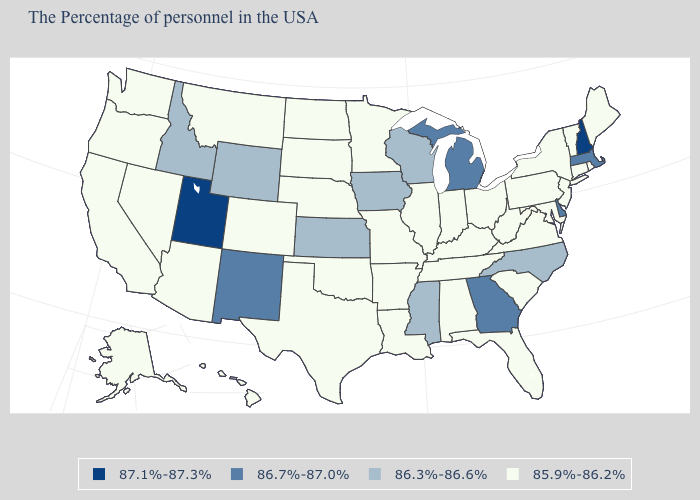Name the states that have a value in the range 85.9%-86.2%?
Be succinct. Maine, Rhode Island, Vermont, Connecticut, New York, New Jersey, Maryland, Pennsylvania, Virginia, South Carolina, West Virginia, Ohio, Florida, Kentucky, Indiana, Alabama, Tennessee, Illinois, Louisiana, Missouri, Arkansas, Minnesota, Nebraska, Oklahoma, Texas, South Dakota, North Dakota, Colorado, Montana, Arizona, Nevada, California, Washington, Oregon, Alaska, Hawaii. Name the states that have a value in the range 87.1%-87.3%?
Be succinct. New Hampshire, Utah. What is the value of Maryland?
Short answer required. 85.9%-86.2%. Name the states that have a value in the range 85.9%-86.2%?
Be succinct. Maine, Rhode Island, Vermont, Connecticut, New York, New Jersey, Maryland, Pennsylvania, Virginia, South Carolina, West Virginia, Ohio, Florida, Kentucky, Indiana, Alabama, Tennessee, Illinois, Louisiana, Missouri, Arkansas, Minnesota, Nebraska, Oklahoma, Texas, South Dakota, North Dakota, Colorado, Montana, Arizona, Nevada, California, Washington, Oregon, Alaska, Hawaii. What is the lowest value in the USA?
Quick response, please. 85.9%-86.2%. Name the states that have a value in the range 86.3%-86.6%?
Concise answer only. North Carolina, Wisconsin, Mississippi, Iowa, Kansas, Wyoming, Idaho. Does the first symbol in the legend represent the smallest category?
Quick response, please. No. What is the value of Arizona?
Quick response, please. 85.9%-86.2%. How many symbols are there in the legend?
Be succinct. 4. What is the value of Tennessee?
Short answer required. 85.9%-86.2%. Does Pennsylvania have the highest value in the Northeast?
Keep it brief. No. Does Mississippi have the lowest value in the USA?
Answer briefly. No. What is the value of South Dakota?
Short answer required. 85.9%-86.2%. Which states have the lowest value in the USA?
Quick response, please. Maine, Rhode Island, Vermont, Connecticut, New York, New Jersey, Maryland, Pennsylvania, Virginia, South Carolina, West Virginia, Ohio, Florida, Kentucky, Indiana, Alabama, Tennessee, Illinois, Louisiana, Missouri, Arkansas, Minnesota, Nebraska, Oklahoma, Texas, South Dakota, North Dakota, Colorado, Montana, Arizona, Nevada, California, Washington, Oregon, Alaska, Hawaii. What is the value of Alabama?
Answer briefly. 85.9%-86.2%. 